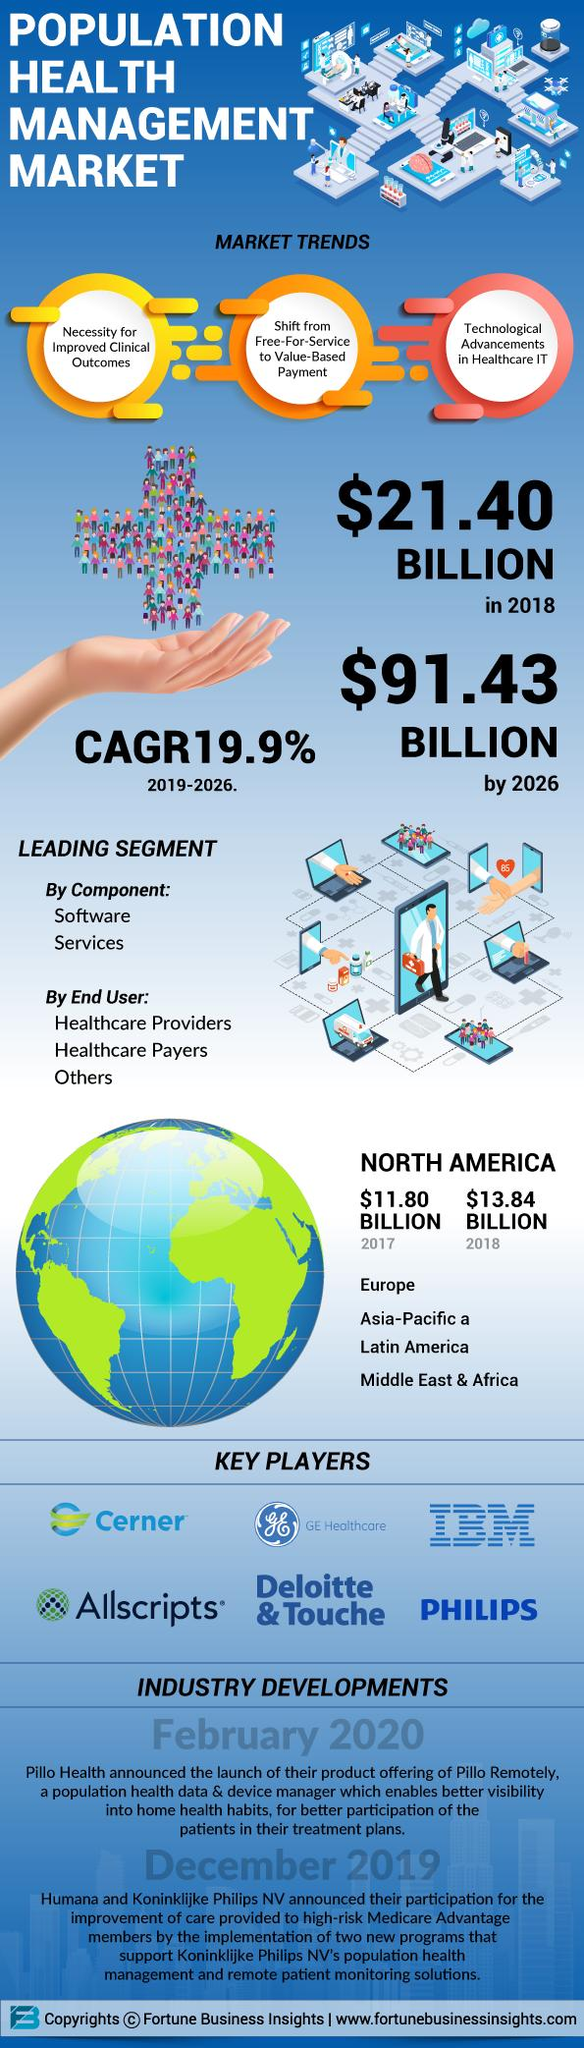Mention a couple of crucial points in this snapshot. There are six key players mentioned in this infographic. 